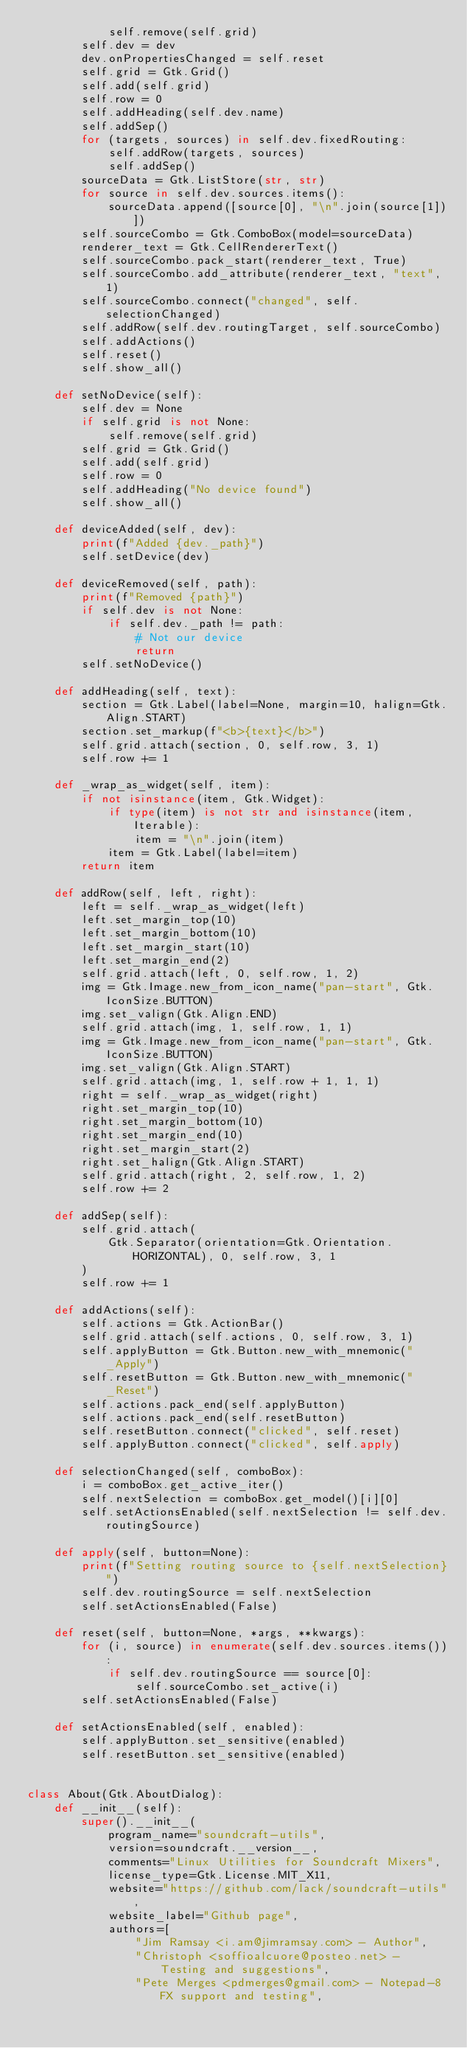Convert code to text. <code><loc_0><loc_0><loc_500><loc_500><_Python_>            self.remove(self.grid)
        self.dev = dev
        dev.onPropertiesChanged = self.reset
        self.grid = Gtk.Grid()
        self.add(self.grid)
        self.row = 0
        self.addHeading(self.dev.name)
        self.addSep()
        for (targets, sources) in self.dev.fixedRouting:
            self.addRow(targets, sources)
            self.addSep()
        sourceData = Gtk.ListStore(str, str)
        for source in self.dev.sources.items():
            sourceData.append([source[0], "\n".join(source[1])])
        self.sourceCombo = Gtk.ComboBox(model=sourceData)
        renderer_text = Gtk.CellRendererText()
        self.sourceCombo.pack_start(renderer_text, True)
        self.sourceCombo.add_attribute(renderer_text, "text", 1)
        self.sourceCombo.connect("changed", self.selectionChanged)
        self.addRow(self.dev.routingTarget, self.sourceCombo)
        self.addActions()
        self.reset()
        self.show_all()

    def setNoDevice(self):
        self.dev = None
        if self.grid is not None:
            self.remove(self.grid)
        self.grid = Gtk.Grid()
        self.add(self.grid)
        self.row = 0
        self.addHeading("No device found")
        self.show_all()

    def deviceAdded(self, dev):
        print(f"Added {dev._path}")
        self.setDevice(dev)

    def deviceRemoved(self, path):
        print(f"Removed {path}")
        if self.dev is not None:
            if self.dev._path != path:
                # Not our device
                return
        self.setNoDevice()

    def addHeading(self, text):
        section = Gtk.Label(label=None, margin=10, halign=Gtk.Align.START)
        section.set_markup(f"<b>{text}</b>")
        self.grid.attach(section, 0, self.row, 3, 1)
        self.row += 1

    def _wrap_as_widget(self, item):
        if not isinstance(item, Gtk.Widget):
            if type(item) is not str and isinstance(item, Iterable):
                item = "\n".join(item)
            item = Gtk.Label(label=item)
        return item

    def addRow(self, left, right):
        left = self._wrap_as_widget(left)
        left.set_margin_top(10)
        left.set_margin_bottom(10)
        left.set_margin_start(10)
        left.set_margin_end(2)
        self.grid.attach(left, 0, self.row, 1, 2)
        img = Gtk.Image.new_from_icon_name("pan-start", Gtk.IconSize.BUTTON)
        img.set_valign(Gtk.Align.END)
        self.grid.attach(img, 1, self.row, 1, 1)
        img = Gtk.Image.new_from_icon_name("pan-start", Gtk.IconSize.BUTTON)
        img.set_valign(Gtk.Align.START)
        self.grid.attach(img, 1, self.row + 1, 1, 1)
        right = self._wrap_as_widget(right)
        right.set_margin_top(10)
        right.set_margin_bottom(10)
        right.set_margin_end(10)
        right.set_margin_start(2)
        right.set_halign(Gtk.Align.START)
        self.grid.attach(right, 2, self.row, 1, 2)
        self.row += 2

    def addSep(self):
        self.grid.attach(
            Gtk.Separator(orientation=Gtk.Orientation.HORIZONTAL), 0, self.row, 3, 1
        )
        self.row += 1

    def addActions(self):
        self.actions = Gtk.ActionBar()
        self.grid.attach(self.actions, 0, self.row, 3, 1)
        self.applyButton = Gtk.Button.new_with_mnemonic("_Apply")
        self.resetButton = Gtk.Button.new_with_mnemonic("_Reset")
        self.actions.pack_end(self.applyButton)
        self.actions.pack_end(self.resetButton)
        self.resetButton.connect("clicked", self.reset)
        self.applyButton.connect("clicked", self.apply)

    def selectionChanged(self, comboBox):
        i = comboBox.get_active_iter()
        self.nextSelection = comboBox.get_model()[i][0]
        self.setActionsEnabled(self.nextSelection != self.dev.routingSource)

    def apply(self, button=None):
        print(f"Setting routing source to {self.nextSelection}")
        self.dev.routingSource = self.nextSelection
        self.setActionsEnabled(False)

    def reset(self, button=None, *args, **kwargs):
        for (i, source) in enumerate(self.dev.sources.items()):
            if self.dev.routingSource == source[0]:
                self.sourceCombo.set_active(i)
        self.setActionsEnabled(False)

    def setActionsEnabled(self, enabled):
        self.applyButton.set_sensitive(enabled)
        self.resetButton.set_sensitive(enabled)


class About(Gtk.AboutDialog):
    def __init__(self):
        super().__init__(
            program_name="soundcraft-utils",
            version=soundcraft.__version__,
            comments="Linux Utilities for Soundcraft Mixers",
            license_type=Gtk.License.MIT_X11,
            website="https://github.com/lack/soundcraft-utils",
            website_label="Github page",
            authors=[
                "Jim Ramsay <i.am@jimramsay.com> - Author",
                "Christoph <soffioalcuore@posteo.net> - Testing and suggestions",
                "Pete Merges <pdmerges@gmail.com> - Notepad-8FX support and testing",</code> 